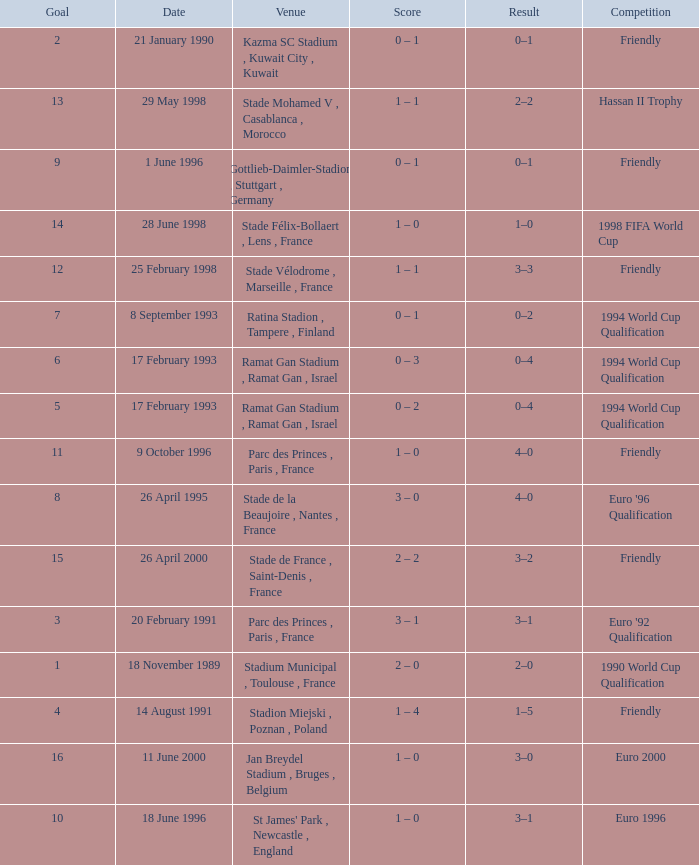What was the date of the game with a result of 3–2? 26 April 2000. 